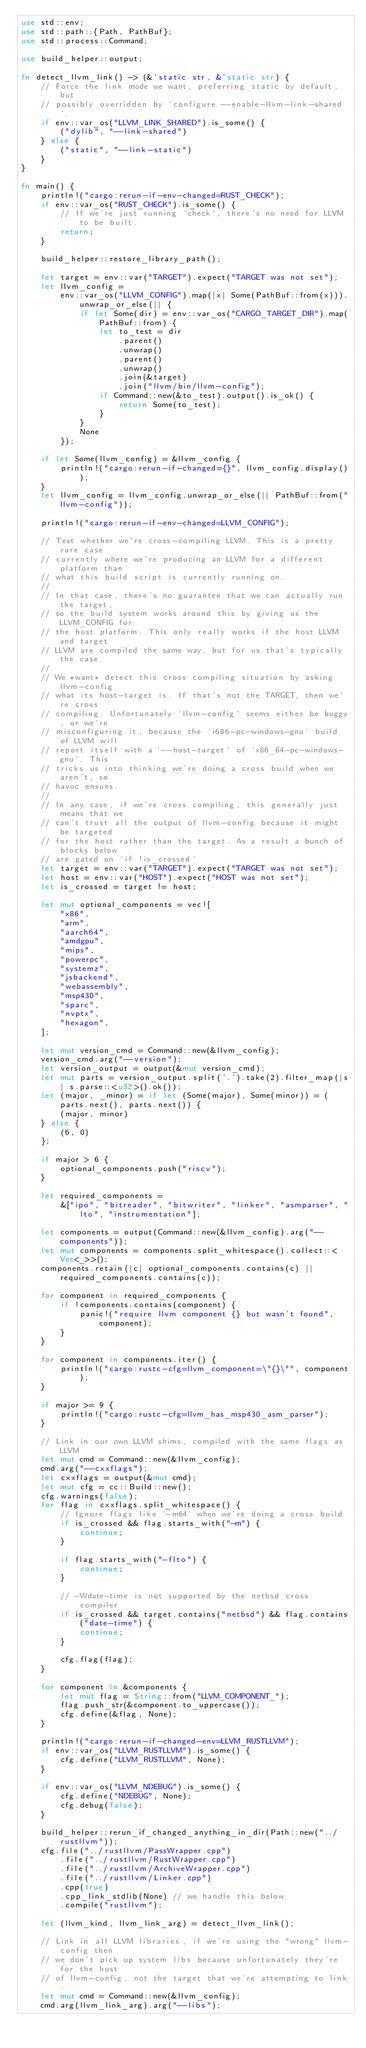Convert code to text. <code><loc_0><loc_0><loc_500><loc_500><_Rust_>use std::env;
use std::path::{Path, PathBuf};
use std::process::Command;

use build_helper::output;

fn detect_llvm_link() -> (&'static str, &'static str) {
    // Force the link mode we want, preferring static by default, but
    // possibly overridden by `configure --enable-llvm-link-shared`.
    if env::var_os("LLVM_LINK_SHARED").is_some() {
        ("dylib", "--link-shared")
    } else {
        ("static", "--link-static")
    }
}

fn main() {
    println!("cargo:rerun-if-env-changed=RUST_CHECK");
    if env::var_os("RUST_CHECK").is_some() {
        // If we're just running `check`, there's no need for LLVM to be built.
        return;
    }

    build_helper::restore_library_path();

    let target = env::var("TARGET").expect("TARGET was not set");
    let llvm_config =
        env::var_os("LLVM_CONFIG").map(|x| Some(PathBuf::from(x))).unwrap_or_else(|| {
            if let Some(dir) = env::var_os("CARGO_TARGET_DIR").map(PathBuf::from) {
                let to_test = dir
                    .parent()
                    .unwrap()
                    .parent()
                    .unwrap()
                    .join(&target)
                    .join("llvm/bin/llvm-config");
                if Command::new(&to_test).output().is_ok() {
                    return Some(to_test);
                }
            }
            None
        });

    if let Some(llvm_config) = &llvm_config {
        println!("cargo:rerun-if-changed={}", llvm_config.display());
    }
    let llvm_config = llvm_config.unwrap_or_else(|| PathBuf::from("llvm-config"));

    println!("cargo:rerun-if-env-changed=LLVM_CONFIG");

    // Test whether we're cross-compiling LLVM. This is a pretty rare case
    // currently where we're producing an LLVM for a different platform than
    // what this build script is currently running on.
    //
    // In that case, there's no guarantee that we can actually run the target,
    // so the build system works around this by giving us the LLVM_CONFIG for
    // the host platform. This only really works if the host LLVM and target
    // LLVM are compiled the same way, but for us that's typically the case.
    //
    // We *want* detect this cross compiling situation by asking llvm-config
    // what its host-target is. If that's not the TARGET, then we're cross
    // compiling. Unfortunately `llvm-config` seems either be buggy, or we're
    // misconfiguring it, because the `i686-pc-windows-gnu` build of LLVM will
    // report itself with a `--host-target` of `x86_64-pc-windows-gnu`. This
    // tricks us into thinking we're doing a cross build when we aren't, so
    // havoc ensues.
    //
    // In any case, if we're cross compiling, this generally just means that we
    // can't trust all the output of llvm-config because it might be targeted
    // for the host rather than the target. As a result a bunch of blocks below
    // are gated on `if !is_crossed`
    let target = env::var("TARGET").expect("TARGET was not set");
    let host = env::var("HOST").expect("HOST was not set");
    let is_crossed = target != host;

    let mut optional_components = vec![
        "x86",
        "arm",
        "aarch64",
        "amdgpu",
        "mips",
        "powerpc",
        "systemz",
        "jsbackend",
        "webassembly",
        "msp430",
        "sparc",
        "nvptx",
        "hexagon",
    ];

    let mut version_cmd = Command::new(&llvm_config);
    version_cmd.arg("--version");
    let version_output = output(&mut version_cmd);
    let mut parts = version_output.split('.').take(2).filter_map(|s| s.parse::<u32>().ok());
    let (major, _minor) = if let (Some(major), Some(minor)) = (parts.next(), parts.next()) {
        (major, minor)
    } else {
        (6, 0)
    };

    if major > 6 {
        optional_components.push("riscv");
    }

    let required_components =
        &["ipo", "bitreader", "bitwriter", "linker", "asmparser", "lto", "instrumentation"];

    let components = output(Command::new(&llvm_config).arg("--components"));
    let mut components = components.split_whitespace().collect::<Vec<_>>();
    components.retain(|c| optional_components.contains(c) || required_components.contains(c));

    for component in required_components {
        if !components.contains(component) {
            panic!("require llvm component {} but wasn't found", component);
        }
    }

    for component in components.iter() {
        println!("cargo:rustc-cfg=llvm_component=\"{}\"", component);
    }

    if major >= 9 {
        println!("cargo:rustc-cfg=llvm_has_msp430_asm_parser");
    }

    // Link in our own LLVM shims, compiled with the same flags as LLVM
    let mut cmd = Command::new(&llvm_config);
    cmd.arg("--cxxflags");
    let cxxflags = output(&mut cmd);
    let mut cfg = cc::Build::new();
    cfg.warnings(false);
    for flag in cxxflags.split_whitespace() {
        // Ignore flags like `-m64` when we're doing a cross build
        if is_crossed && flag.starts_with("-m") {
            continue;
        }

        if flag.starts_with("-flto") {
            continue;
        }

        // -Wdate-time is not supported by the netbsd cross compiler
        if is_crossed && target.contains("netbsd") && flag.contains("date-time") {
            continue;
        }

        cfg.flag(flag);
    }

    for component in &components {
        let mut flag = String::from("LLVM_COMPONENT_");
        flag.push_str(&component.to_uppercase());
        cfg.define(&flag, None);
    }

    println!("cargo:rerun-if-changed-env=LLVM_RUSTLLVM");
    if env::var_os("LLVM_RUSTLLVM").is_some() {
        cfg.define("LLVM_RUSTLLVM", None);
    }

    if env::var_os("LLVM_NDEBUG").is_some() {
        cfg.define("NDEBUG", None);
        cfg.debug(false);
    }

    build_helper::rerun_if_changed_anything_in_dir(Path::new("../rustllvm"));
    cfg.file("../rustllvm/PassWrapper.cpp")
        .file("../rustllvm/RustWrapper.cpp")
        .file("../rustllvm/ArchiveWrapper.cpp")
        .file("../rustllvm/Linker.cpp")
        .cpp(true)
        .cpp_link_stdlib(None) // we handle this below
        .compile("rustllvm");

    let (llvm_kind, llvm_link_arg) = detect_llvm_link();

    // Link in all LLVM libraries, if we're using the "wrong" llvm-config then
    // we don't pick up system libs because unfortunately they're for the host
    // of llvm-config, not the target that we're attempting to link.
    let mut cmd = Command::new(&llvm_config);
    cmd.arg(llvm_link_arg).arg("--libs");
</code> 